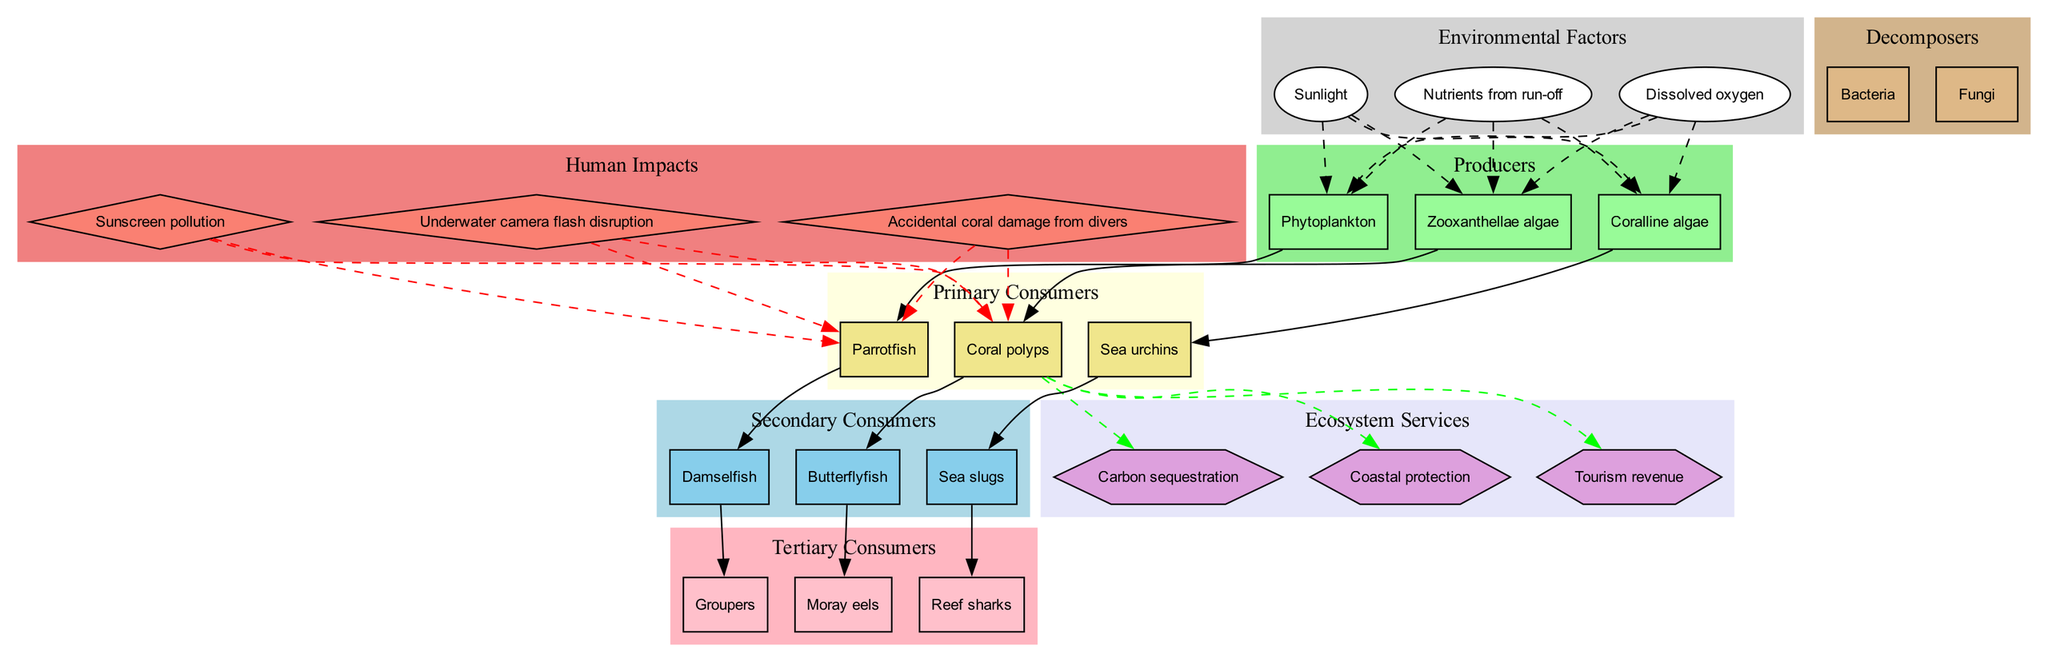what are the producers in the coral reef food chain? The producers listed in the diagram are the organisms that create energy through photosynthesis or other means. In this case, the diagram specifically identifies Zooxanthellae algae, Phytoplankton, and Coralline algae as the producers.
Answer: Zooxanthellae algae, Phytoplankton, Coralline algae how many primary consumers are in the diagram? The primary consumers are the organisms that eat the producers. The diagram lists three primary consumers: Coral polyps, Parrotfish, and Sea urchins. Thus, by counting the listed primary consumers, there are three.
Answer: 3 which environmental factor directly influences the producers? The environmental factors affecting the producers as shown in the diagram include Sunlight, Nutrients from run-off, and Dissolved oxygen. All these factors provide the necessary conditions for the producers to thrive.
Answer: Sunlight, Nutrients from run-off, Dissolved oxygen what impact does underwater camera flash have on coral polyps? According to the diagram, the underwater camera flash disruption is shown as a human impact that influences the coral polyps. The relationship is depicted with a dashed red line connecting the impact to the coral polyps, indicating a negative effect.
Answer: Disruption name one tertiary consumer in the coral reef food chain. The tertiary consumers are at the top of the food chain and include apex predators. The diagram mentions Moray eels, Groupers, and Reef sharks as tertiary consumers.
Answer: Moray eels how do secondary consumers relate to primary consumers in the food chain? Secondary consumers feed on primary consumers, as indicated by the arrows in the diagram. For instance, Butterflyfish eat Coral polyps, Damselfish eat Parrotfish, and Sea slugs eat Sea urchins, demonstrating a direct food relationship between the two consumer levels.
Answer: They eat them what are two ecosystem services provided by the coral reef? Ecosystem services are benefits that humans derive from nature. The diagram links carbon sequestration and tourism revenue as examples of ecosystem services provided by the coral reef ecosystem, illustrating the broader importance of coral reefs.
Answer: Carbon sequestration, tourism revenue which human impact is related to sunscreen? The diagram indicates sunscreen pollution as one of the human impacts that affect the coral reef ecosystem. This is shown as a diamond-shaped node connected to the coral polyps, illustrating its potential harmful consequences.
Answer: Sunscreen pollution how many decomposers are represented in the coral reef food chain? The decomposers are responsible for breaking down dead organic matter. The diagram specifically lists two decomposers: Bacteria and Fungi. Therefore, counting these results in a total of two decomposers present in the diagram.
Answer: 2 